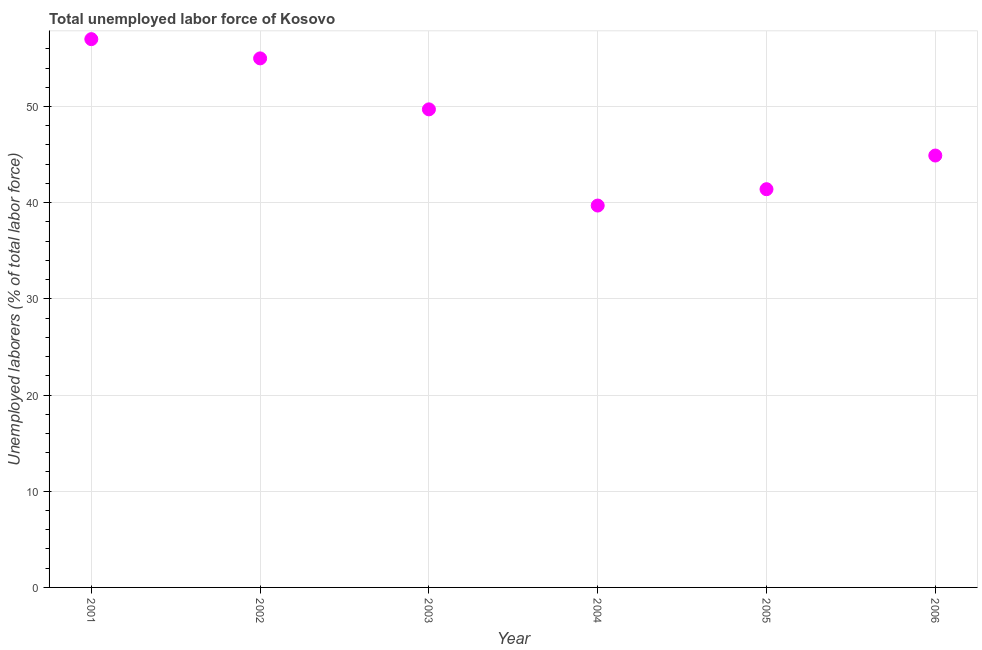What is the total unemployed labour force in 2005?
Provide a succinct answer. 41.4. Across all years, what is the maximum total unemployed labour force?
Provide a short and direct response. 57. Across all years, what is the minimum total unemployed labour force?
Make the answer very short. 39.7. What is the sum of the total unemployed labour force?
Ensure brevity in your answer.  287.7. What is the difference between the total unemployed labour force in 2002 and 2004?
Offer a terse response. 15.3. What is the average total unemployed labour force per year?
Offer a very short reply. 47.95. What is the median total unemployed labour force?
Your answer should be very brief. 47.3. Do a majority of the years between 2004 and 2003 (inclusive) have total unemployed labour force greater than 52 %?
Offer a terse response. No. What is the ratio of the total unemployed labour force in 2003 to that in 2004?
Give a very brief answer. 1.25. Is the total unemployed labour force in 2002 less than that in 2005?
Offer a very short reply. No. What is the difference between the highest and the lowest total unemployed labour force?
Provide a succinct answer. 17.3. Does the total unemployed labour force monotonically increase over the years?
Offer a terse response. No. Are the values on the major ticks of Y-axis written in scientific E-notation?
Your response must be concise. No. What is the title of the graph?
Give a very brief answer. Total unemployed labor force of Kosovo. What is the label or title of the Y-axis?
Offer a very short reply. Unemployed laborers (% of total labor force). What is the Unemployed laborers (% of total labor force) in 2002?
Your answer should be compact. 55. What is the Unemployed laborers (% of total labor force) in 2003?
Provide a short and direct response. 49.7. What is the Unemployed laborers (% of total labor force) in 2004?
Your response must be concise. 39.7. What is the Unemployed laborers (% of total labor force) in 2005?
Your response must be concise. 41.4. What is the Unemployed laborers (% of total labor force) in 2006?
Provide a succinct answer. 44.9. What is the difference between the Unemployed laborers (% of total labor force) in 2001 and 2004?
Keep it short and to the point. 17.3. What is the difference between the Unemployed laborers (% of total labor force) in 2001 and 2006?
Give a very brief answer. 12.1. What is the difference between the Unemployed laborers (% of total labor force) in 2002 and 2006?
Ensure brevity in your answer.  10.1. What is the difference between the Unemployed laborers (% of total labor force) in 2003 and 2004?
Provide a succinct answer. 10. What is the difference between the Unemployed laborers (% of total labor force) in 2003 and 2005?
Keep it short and to the point. 8.3. What is the difference between the Unemployed laborers (% of total labor force) in 2003 and 2006?
Provide a short and direct response. 4.8. What is the ratio of the Unemployed laborers (% of total labor force) in 2001 to that in 2002?
Your answer should be compact. 1.04. What is the ratio of the Unemployed laborers (% of total labor force) in 2001 to that in 2003?
Your answer should be very brief. 1.15. What is the ratio of the Unemployed laborers (% of total labor force) in 2001 to that in 2004?
Ensure brevity in your answer.  1.44. What is the ratio of the Unemployed laborers (% of total labor force) in 2001 to that in 2005?
Your answer should be very brief. 1.38. What is the ratio of the Unemployed laborers (% of total labor force) in 2001 to that in 2006?
Your response must be concise. 1.27. What is the ratio of the Unemployed laborers (% of total labor force) in 2002 to that in 2003?
Ensure brevity in your answer.  1.11. What is the ratio of the Unemployed laborers (% of total labor force) in 2002 to that in 2004?
Provide a short and direct response. 1.39. What is the ratio of the Unemployed laborers (% of total labor force) in 2002 to that in 2005?
Your answer should be compact. 1.33. What is the ratio of the Unemployed laborers (% of total labor force) in 2002 to that in 2006?
Ensure brevity in your answer.  1.23. What is the ratio of the Unemployed laborers (% of total labor force) in 2003 to that in 2004?
Keep it short and to the point. 1.25. What is the ratio of the Unemployed laborers (% of total labor force) in 2003 to that in 2005?
Provide a short and direct response. 1.2. What is the ratio of the Unemployed laborers (% of total labor force) in 2003 to that in 2006?
Make the answer very short. 1.11. What is the ratio of the Unemployed laborers (% of total labor force) in 2004 to that in 2006?
Keep it short and to the point. 0.88. What is the ratio of the Unemployed laborers (% of total labor force) in 2005 to that in 2006?
Keep it short and to the point. 0.92. 